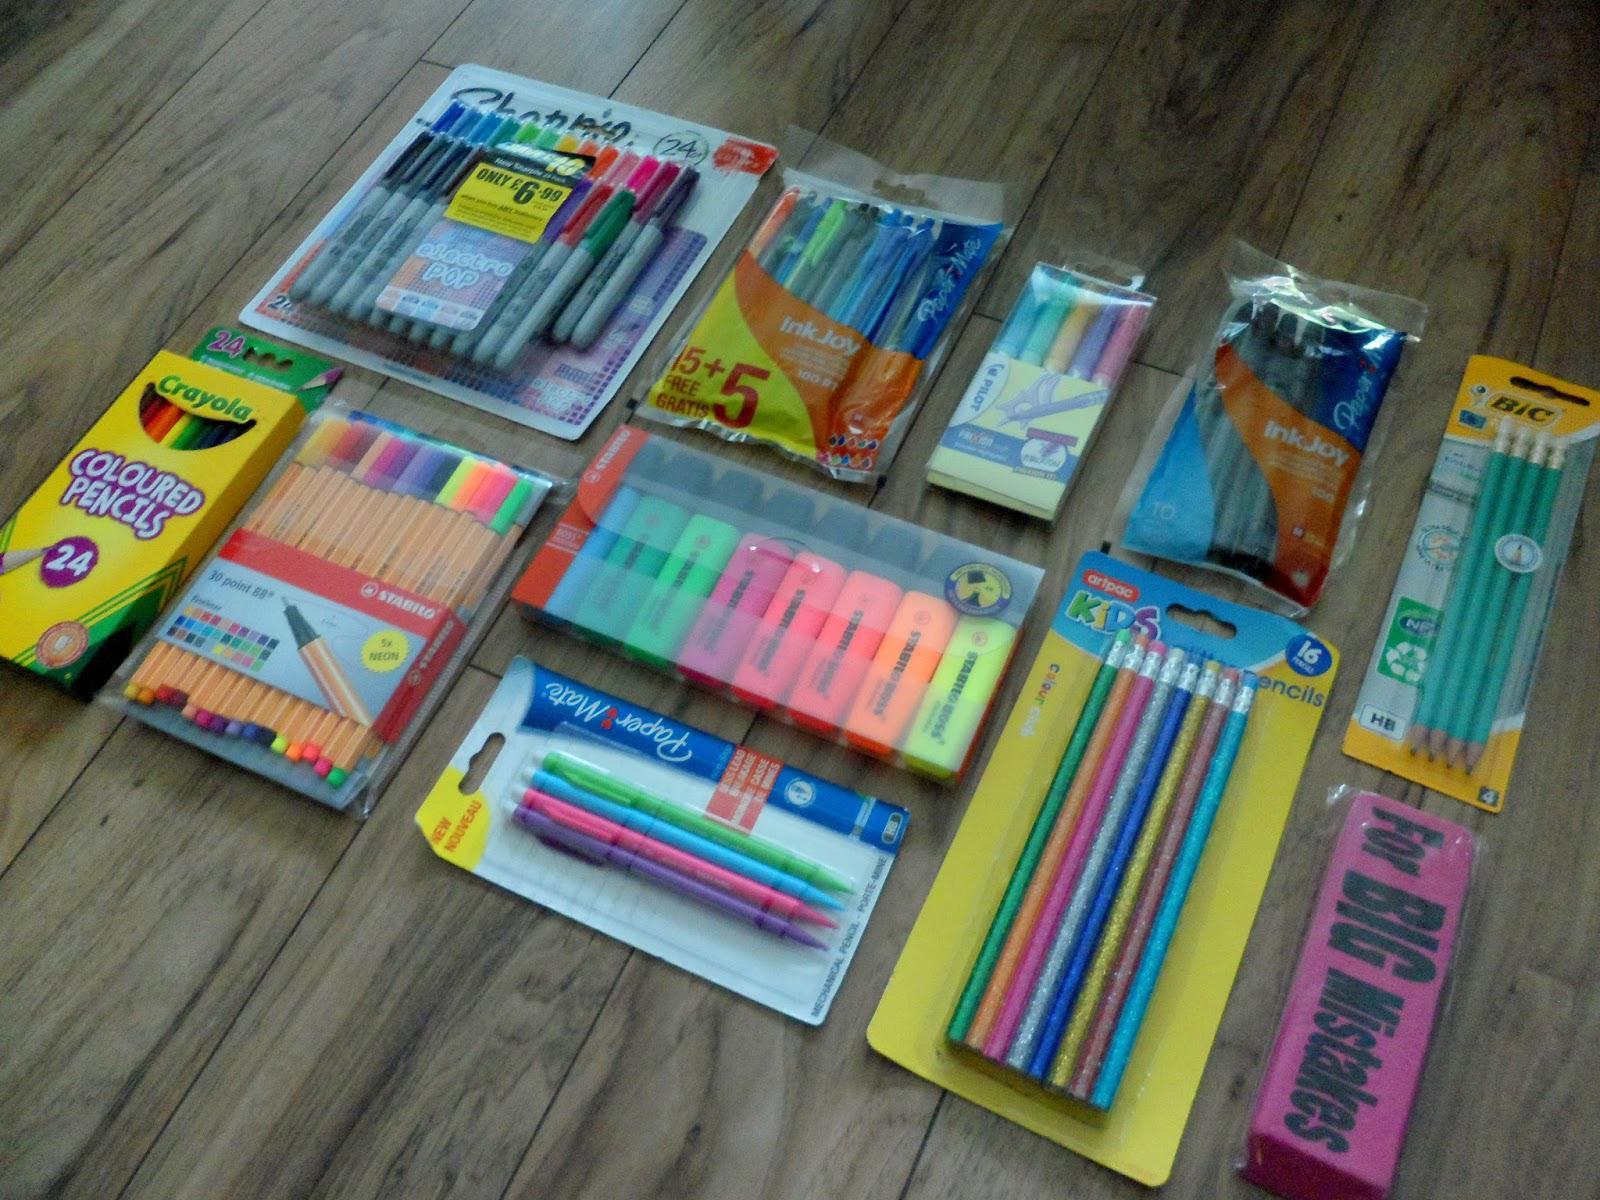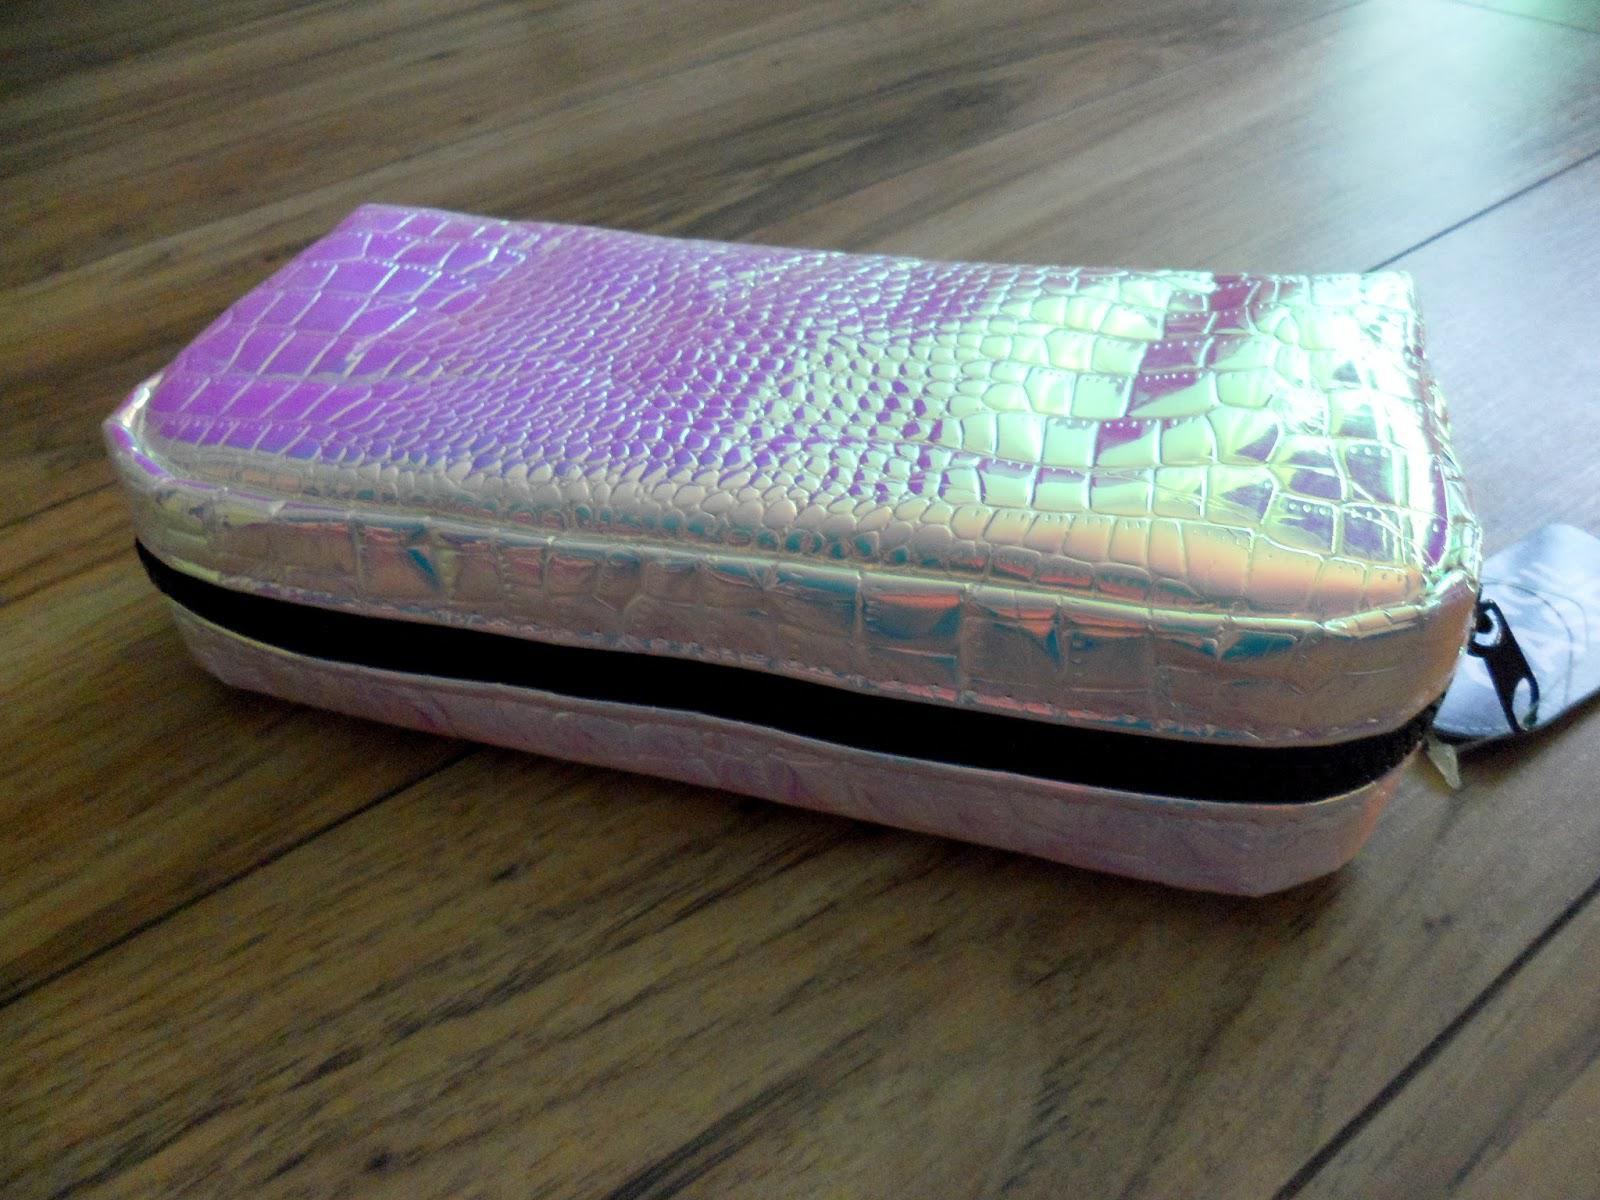The first image is the image on the left, the second image is the image on the right. Considering the images on both sides, is "Left and right images each show one soft-sided tube-shaped zipper case displayed at the same angle." valid? Answer yes or no. No. The first image is the image on the left, the second image is the image on the right. Given the left and right images, does the statement "There are two pencil cases and they both have a similar long shape." hold true? Answer yes or no. No. 